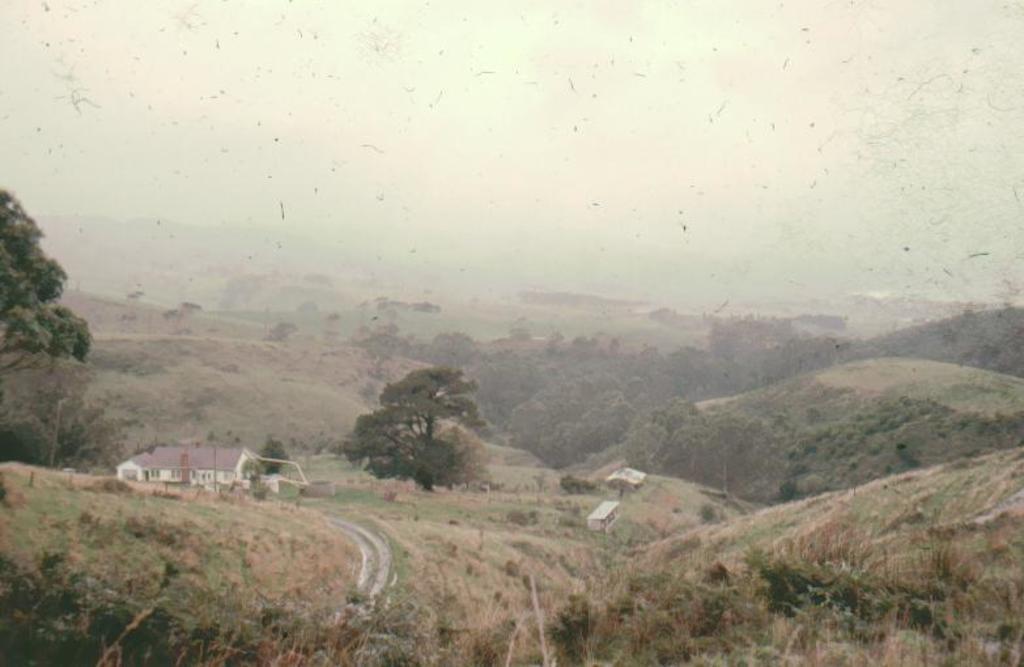Describe this image in one or two sentences. In this image in the front there are plants. In the background there are trees and there are houses, there are mountains and the sky is cloudy. 